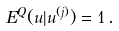<formula> <loc_0><loc_0><loc_500><loc_500>E ^ { Q } ( u | u ^ { ( j ) } ) = 1 \, .</formula> 